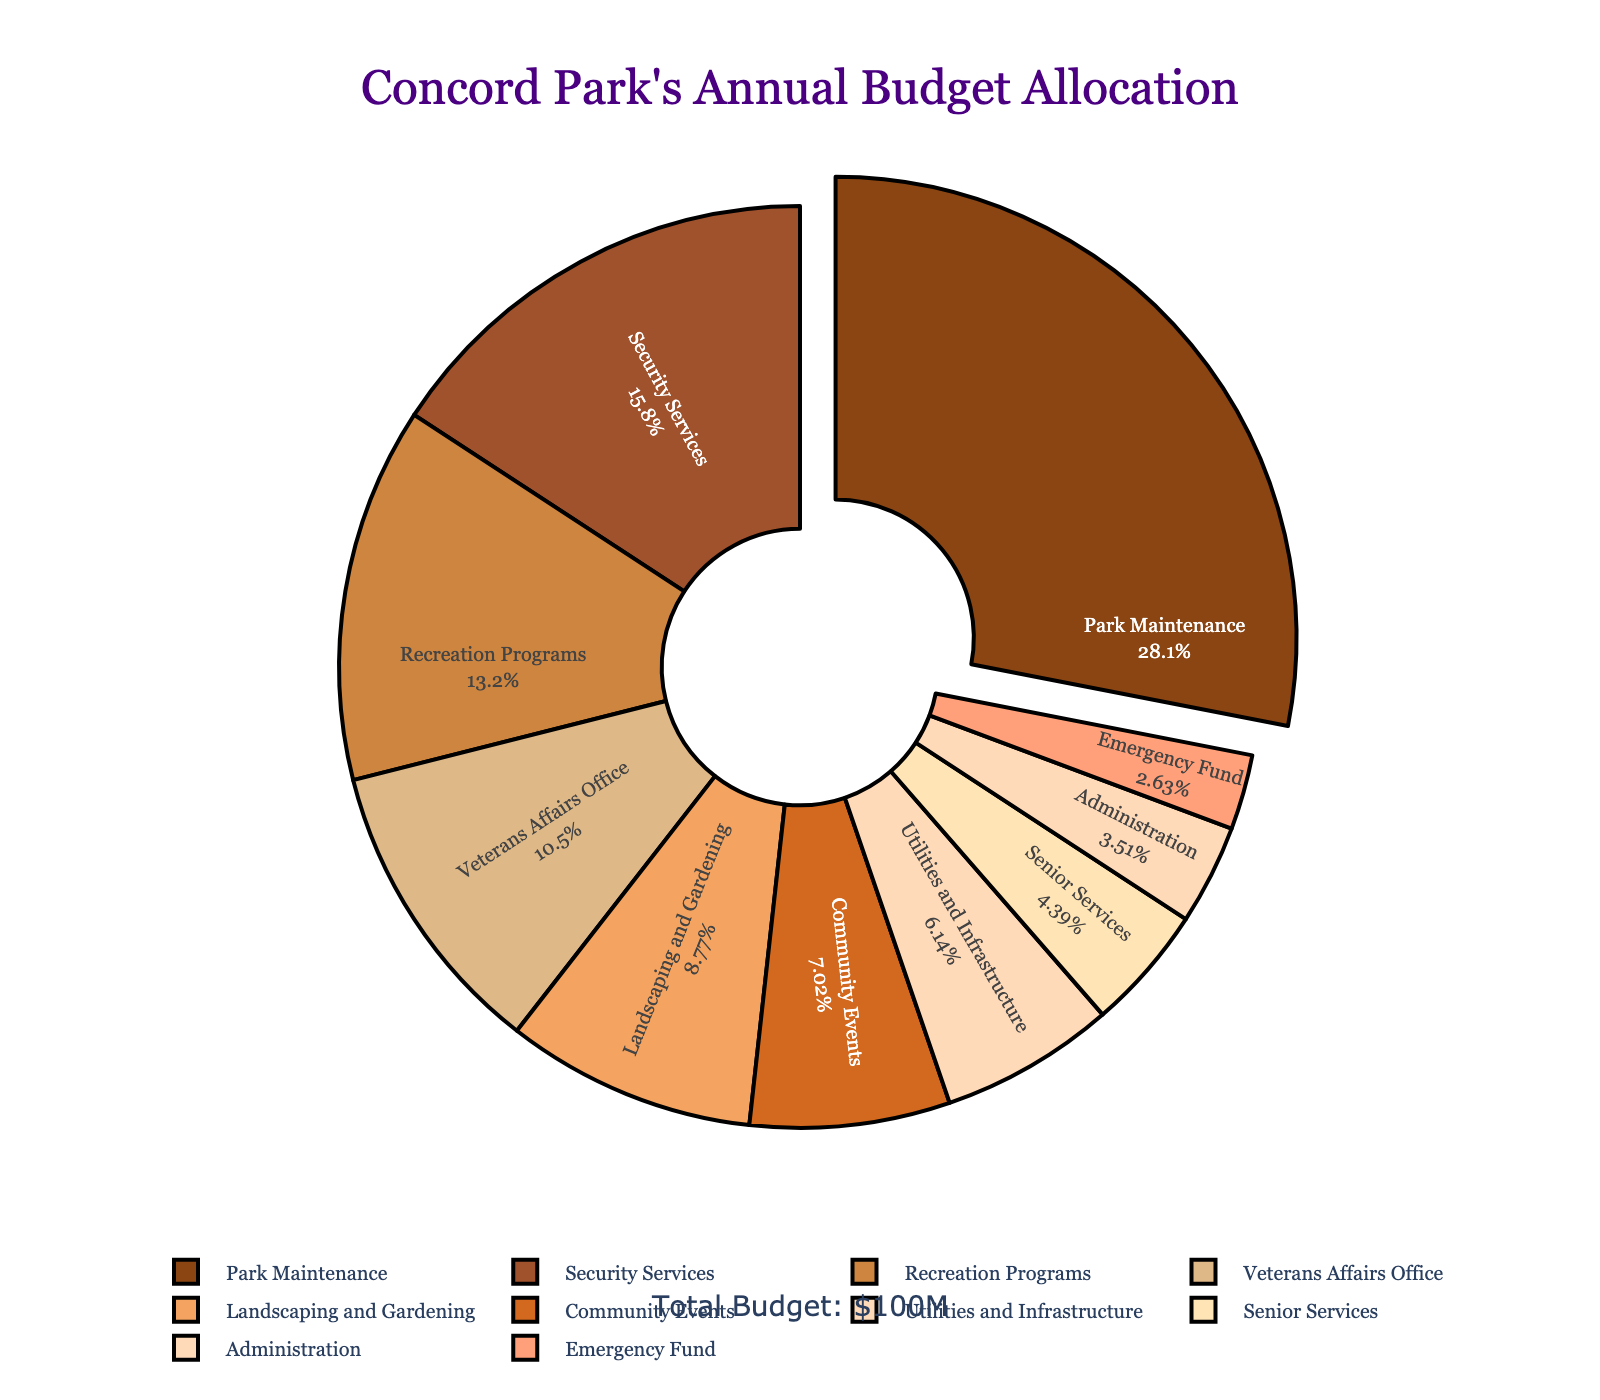What percentage of the annual budget is allocated to Park Maintenance? Look at the pie chart and find the segment labeled 'Park Maintenance.' The percentage is indicated on the chart.
Answer: 32% Which department receives a smaller budget allocation than Security Services but larger than Community Events? Find 'Security Services' and 'Community Events' on the pie chart. Identify the budget allocations and look for a segment with an allocation between these two percentages. 'Recreation Programs' has a budget allocation between the two.
Answer: Recreation Programs How much more budget is allocated to Park Maintenance compared to Security Services? Look for 'Park Maintenance' and 'Security Services' segments. Subtract the budget percentage of 'Security Services' from 'Park Maintenance.' It is 32% - 18%.
Answer: 14% Which departments receive less than 10% of the budget? Scan the pie chart for segments with less than 10% allocations. These departments are 'Community Events,' 'Utilities and Infrastructure,' 'Senior Services,' 'Administration,' and 'Emergency Fund.'
Answer: Community Events, Utilities and Infrastructure, Senior Services, Administration, Emergency Fund How many departments receive an allocation greater than or equal to 10% of the budget? Count the segments that have a budget allocation of 10% or more in the pie chart. There are 'Park Maintenance,' 'Security Services,' 'Recreation Programs,' 'Veterans Affairs Office,' and 'Landscaping and Gardening.'
Answer: 5 Is the Veterans Affairs Office budget more or less than the combined budget of Administration and Emergency Fund? Find the percentages for 'Veterans Affairs Office,' 'Administration,' and 'Emergency Fund.' Combine the allocations of 'Administration' and 'Emergency Fund' (4% + 3% = 7%). Compare it with Veterans Affairs Office (12%).
Answer: More What is the approximate combined budget allocation for Senior Services and Utilities and Infrastructure? Find the percentages for 'Senior Services' and 'Utilities and Infrastructure' and add them together. The sum is 5% + 7%.
Answer: 12% Which department has the second largest budget allocation? Identify the department with the second largest segment after 'Park Maintenance' on the pie chart. The second largest segment is 'Security Services.'
Answer: Security Services Which department's budget is indicated by a pulled-out segment in the pie chart? Look for the segment that is visually pulled out from the pie chart. This segment represents 'Park Maintenance.'
Answer: Park Maintenance What is the combined budget allocation for Administration, Senior Services, and Community Events? Find the budget percentages for 'Administration,' 'Senior Services,' and 'Community Events.' Add these values together: 4% + 5% + 8%.
Answer: 17% 